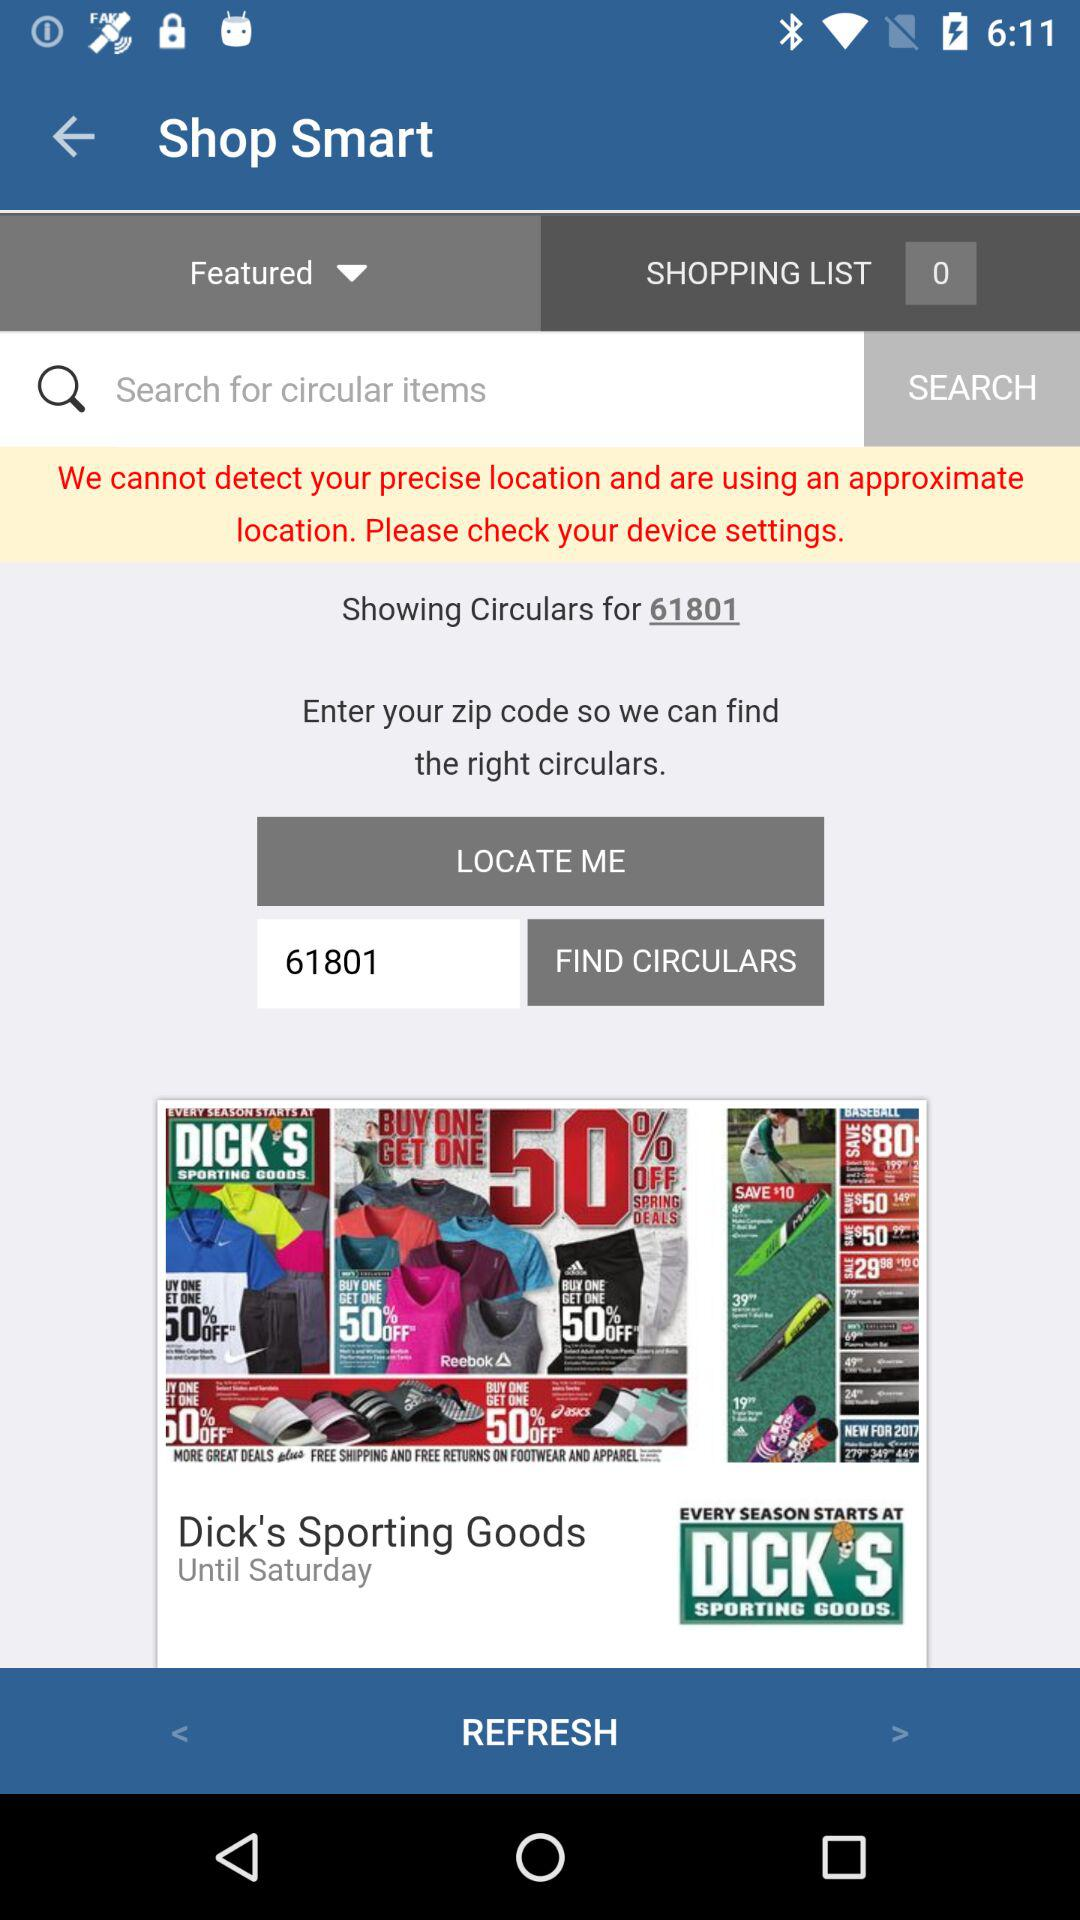What is the zip code shown there? The shown zip code is 61801. 